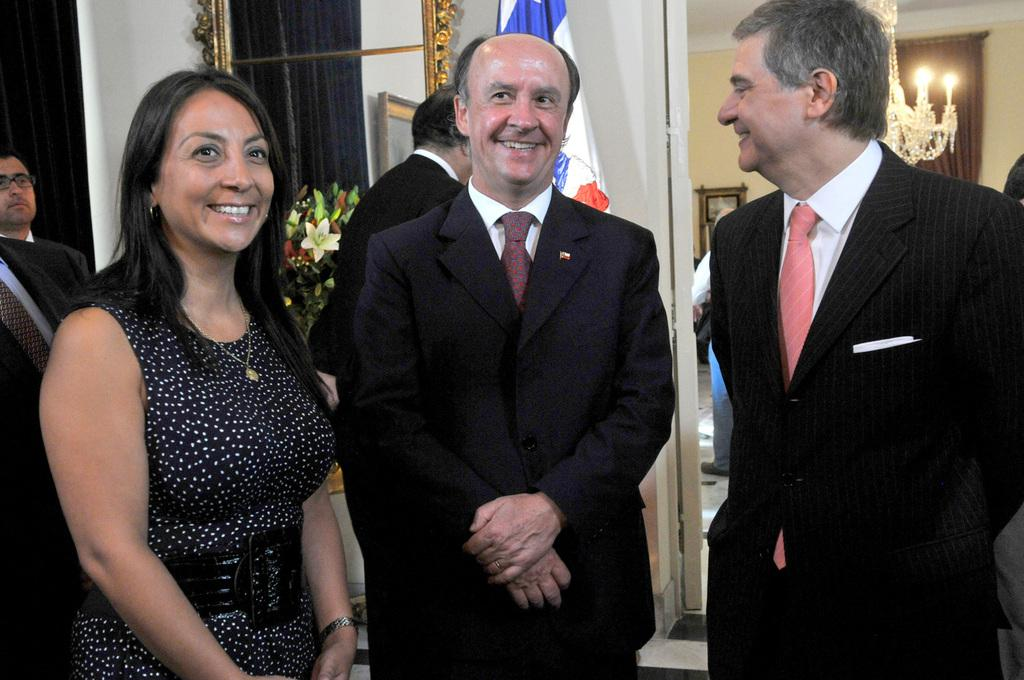What can be seen in the image regarding the people present? There are people standing in the image. What are the men wearing in the image? The men are wearing formal suits in the image. What is the symbolic item visible in the image? There is a flag visible in the image. What type of decorative item can be seen in the image? There are flowers in a vase in the image. What type of lighting fixture is present in the image? There is a chandelier in the image. What type of silk is being spun by the person in the image? There is no person spinning silk in the image; the people are standing and wearing formal suits. What is the chance of winning a prize in the image? There is no mention of a prize or chance in the image; it features people standing, a flag, flowers in a vase, and a chandelier. 